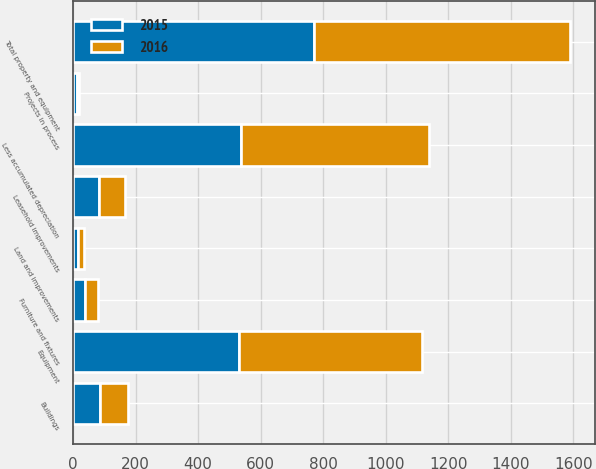Convert chart. <chart><loc_0><loc_0><loc_500><loc_500><stacked_bar_chart><ecel><fcel>Equipment<fcel>Buildings<fcel>Leasehold improvements<fcel>Furniture and fixtures<fcel>Land and improvements<fcel>Projects in process<fcel>Total property and equipment<fcel>Less accumulated depreciation<nl><fcel>2016<fcel>585.5<fcel>88.3<fcel>84.3<fcel>40.4<fcel>17<fcel>5<fcel>820.5<fcel>600<nl><fcel>2015<fcel>529.8<fcel>87.3<fcel>83.3<fcel>39.6<fcel>17<fcel>13<fcel>770<fcel>538.2<nl></chart> 